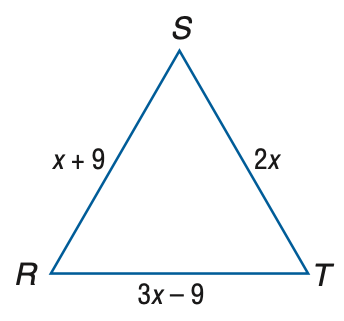Answer the mathemtical geometry problem and directly provide the correct option letter.
Question: Find the measure of S T of equilateral triangle R S T if R S = x + 9, S T = 2 x, and R T = 3 x - 9.
Choices: A: 9 B: 12 C: 15 D: 18 D 